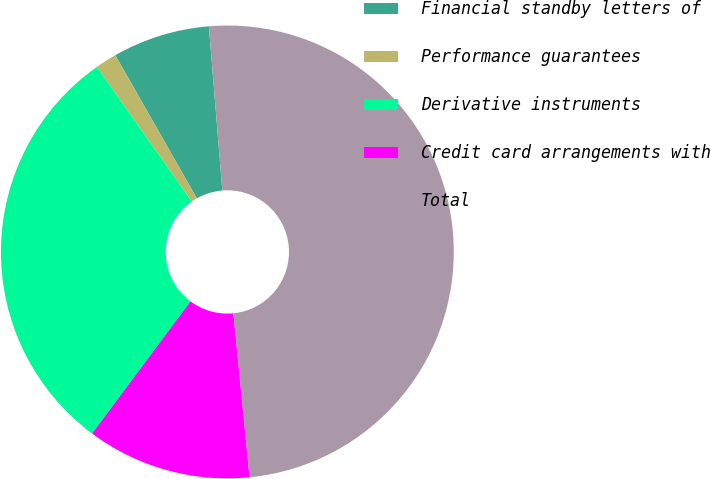Convert chart to OTSL. <chart><loc_0><loc_0><loc_500><loc_500><pie_chart><fcel>Financial standby letters of<fcel>Performance guarantees<fcel>Derivative instruments<fcel>Credit card arrangements with<fcel>Total<nl><fcel>6.94%<fcel>1.54%<fcel>30.03%<fcel>11.76%<fcel>49.74%<nl></chart> 